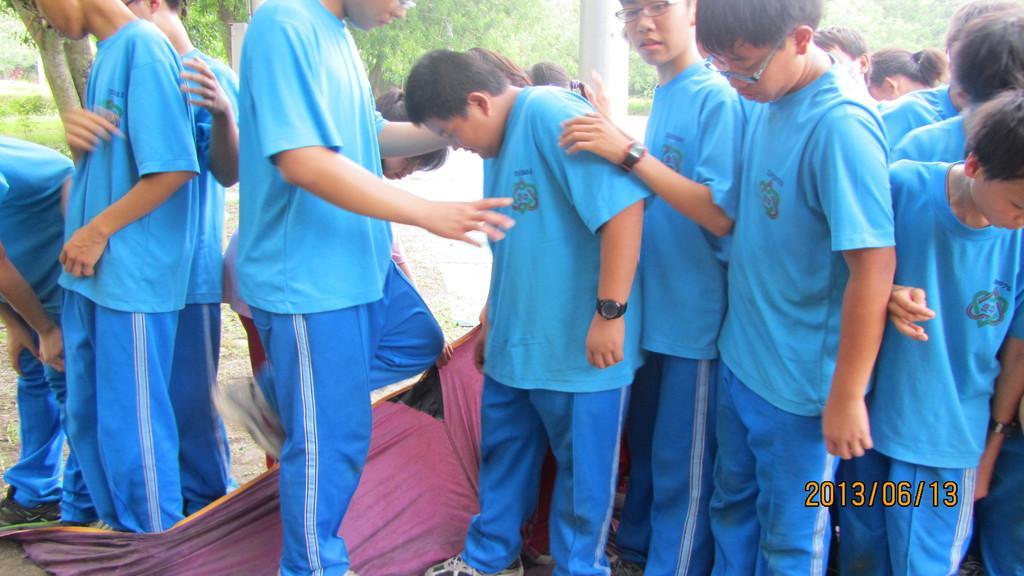Please provide a concise description of this image. As we can see in the image there is cloth, trees, grass and group of people wearing sky blue color t shirts. 